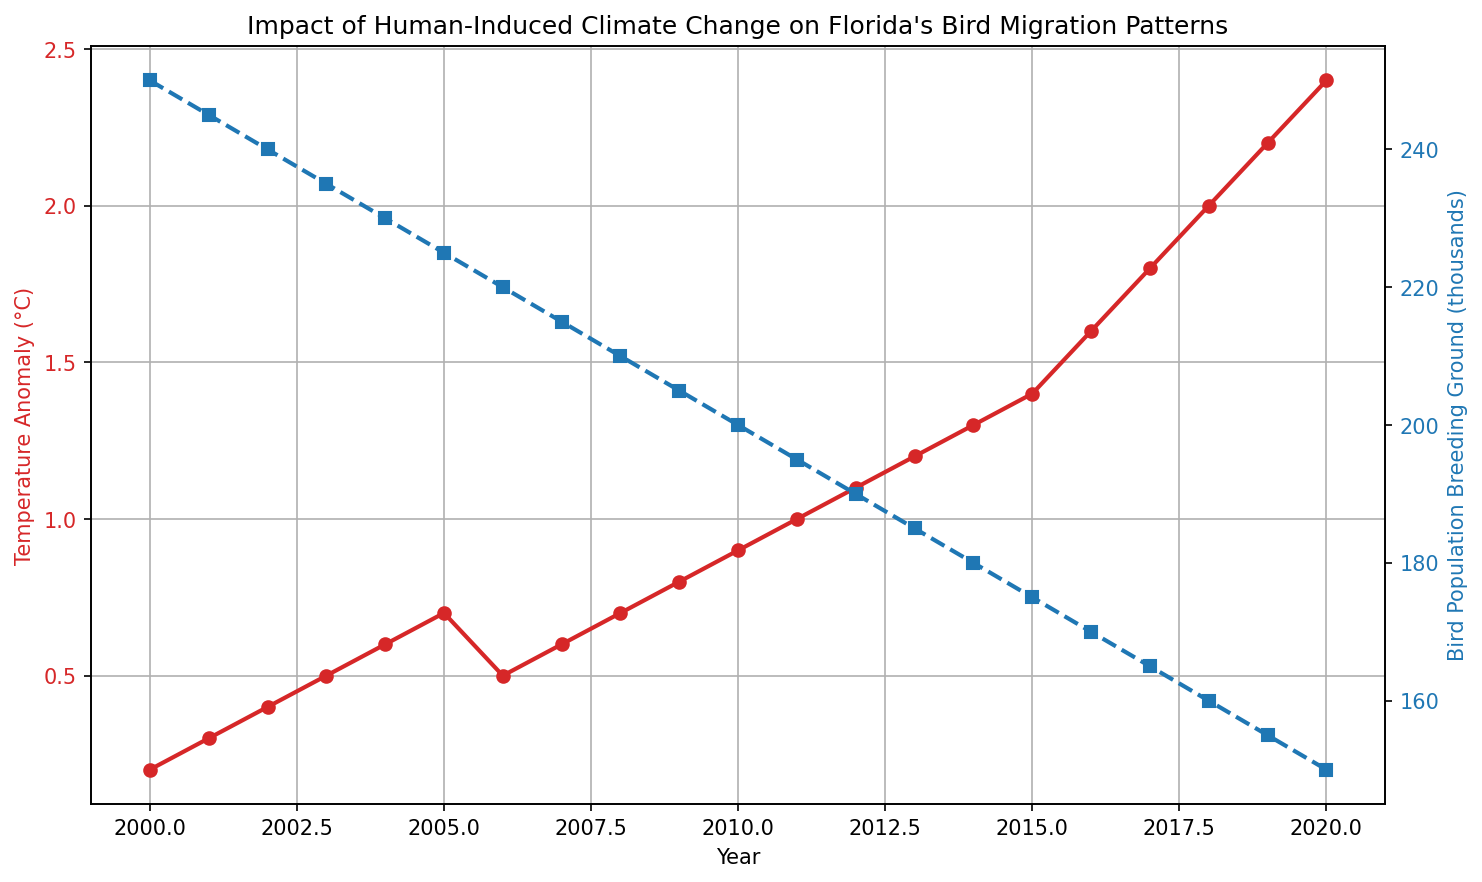What is the temperature anomaly in 2010? In 2010, the temperature anomaly can be observed by locating the year 2010 on the x-axis and then checking the corresponding value on the red line plot.
Answer: 0.9°C By how much did the bird population breeding ground decrease from 2000 to 2020? To find the decrease, subtract the bird population in 2020 from the bird population in 2000: 250,000 - 150,000 = 100,000.
Answer: 100,000 In which year did the temperature anomaly reach 1.2°C? Locate the point on the red line where the temperature anomaly value is 1.2°C. Then identify the corresponding year on the x-axis.
Answer: 2013 Which year experienced a higher temperature anomaly: 2005 or 2015? Check the red line plot for the temperature anomaly values corresponding to the years 2005 and 2015 and compare them.
Answer: 2015 What is the trend in bird population breeding grounds from 2000 to 2020? The blue dashed line, representing bird population breeding grounds, shows a decreasing trend from 250,000 in 2000 to 150,000 in 2020.
Answer: Decreasing What was the rate of increase in temperature anomaly from 2010 to 2020? Calculate the difference in temperature anomaly between 2010 and 2020, then divide by the number of years: (2.4 - 0.9) / 10 = 0.15°C per year.
Answer: 0.15°C per year Between which consecutive years did the bird population breeding ground decrease the most? Observe the steepest decline in the blue dashed line by comparing the differences between consecutive data points: between 2016 to 2017 (from 170,000 to 165,000), the decrease is -5,000 which is the largest compared to other years.
Answer: 2016 to 2017 What color represents the bird population breeding ground on the plot? Identify the color of the dashed line.
Answer: Blue Did the temperature anomaly ever plateau, and if so, between which years? Check the red line for any sections where the values remain consistent.
Answer: 2005 to 2006 